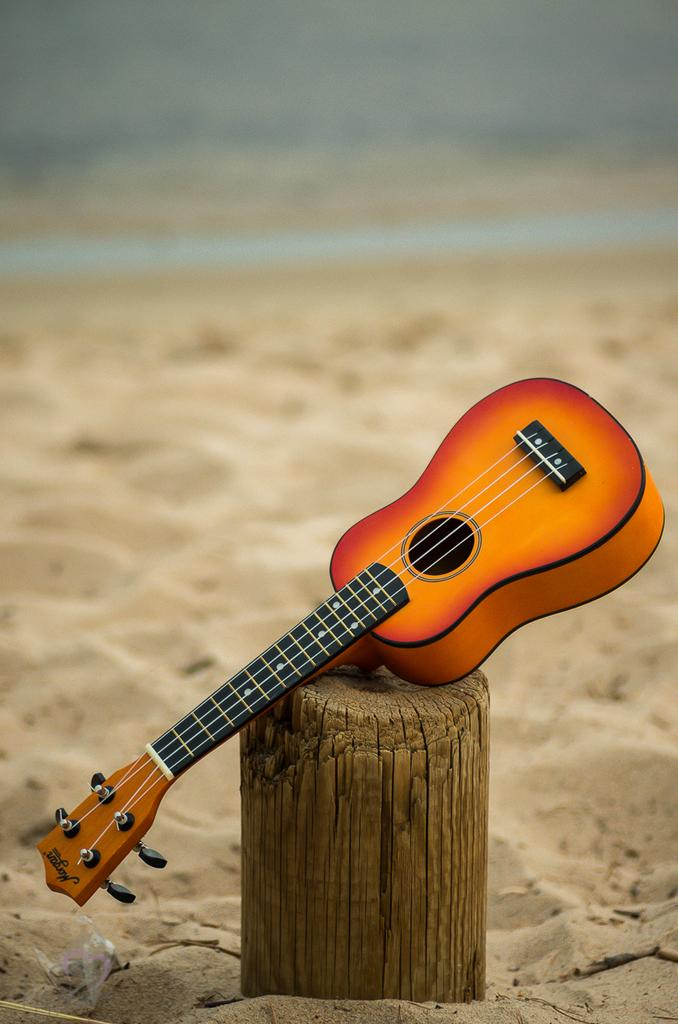What is the main object in the middle of the image? There is a guitar in the middle of the image. What type of surface is visible behind the guitar? There is sand visible behind the guitar. What type of cub can be seen playing with the guitar in the image? There is no cub or any animal present in the image; it features a guitar and sand. What type of sail is attached to the guitar in the image? There is no sail or any attachment to the guitar in the image; it is a standalone instrument. 